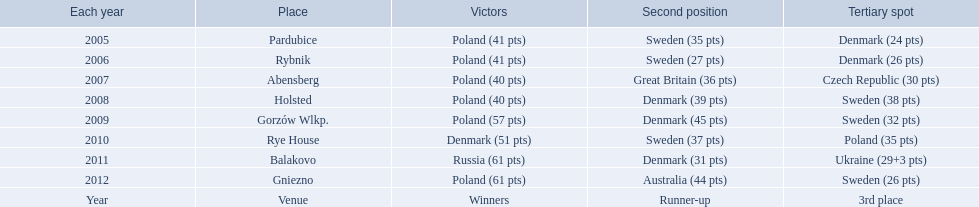Did holland win the 2010 championship? if not who did? Rye House. What did position did holland they rank? 3rd place. 